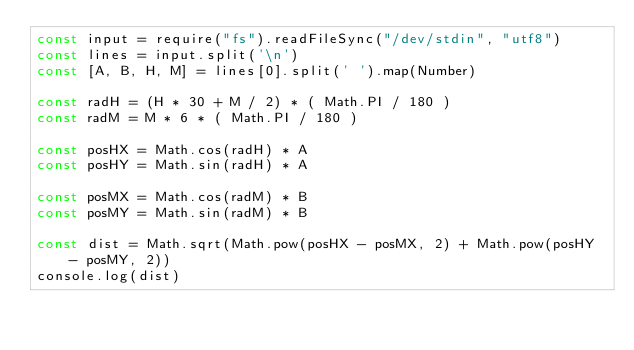Convert code to text. <code><loc_0><loc_0><loc_500><loc_500><_JavaScript_>const input = require("fs").readFileSync("/dev/stdin", "utf8")
const lines = input.split('\n')
const [A, B, H, M] = lines[0].split(' ').map(Number)

const radH = (H * 30 + M / 2) * ( Math.PI / 180 )
const radM = M * 6 * ( Math.PI / 180 )

const posHX = Math.cos(radH) * A
const posHY = Math.sin(radH) * A

const posMX = Math.cos(radM) * B
const posMY = Math.sin(radM) * B

const dist = Math.sqrt(Math.pow(posHX - posMX, 2) + Math.pow(posHY - posMY, 2))
console.log(dist)</code> 